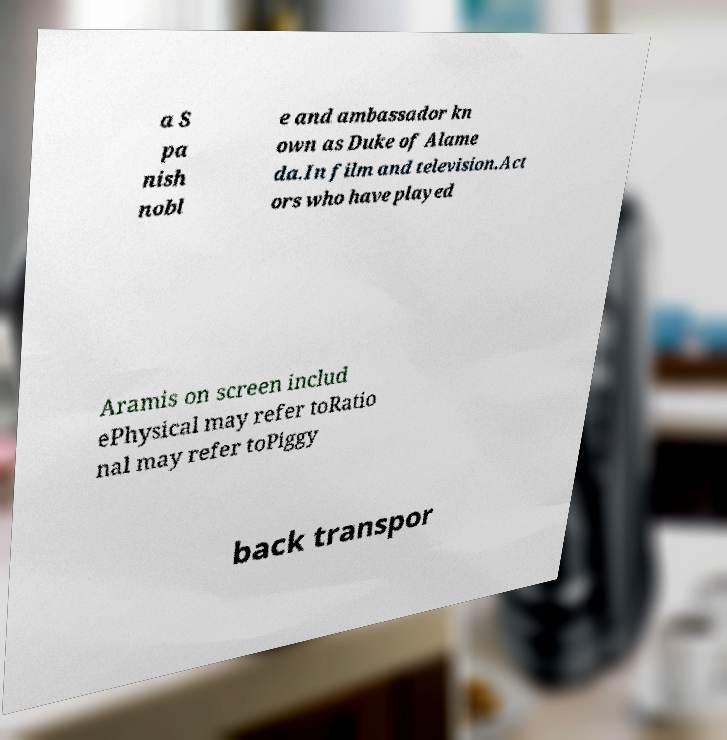Can you accurately transcribe the text from the provided image for me? a S pa nish nobl e and ambassador kn own as Duke of Alame da.In film and television.Act ors who have played Aramis on screen includ ePhysical may refer toRatio nal may refer toPiggy back transpor 